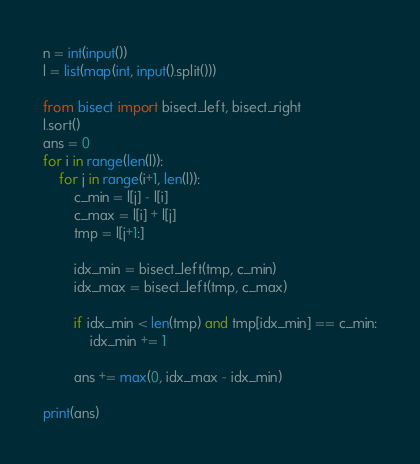Convert code to text. <code><loc_0><loc_0><loc_500><loc_500><_Python_>n = int(input())
l = list(map(int, input().split()))

from bisect import bisect_left, bisect_right
l.sort()
ans = 0
for i in range(len(l)):
    for j in range(i+1, len(l)):
        c_min = l[j] - l[i]
        c_max = l[i] + l[j]
        tmp = l[j+1:]

        idx_min = bisect_left(tmp, c_min)
        idx_max = bisect_left(tmp, c_max)

        if idx_min < len(tmp) and tmp[idx_min] == c_min:
            idx_min += 1

        ans += max(0, idx_max - idx_min)

print(ans)
</code> 